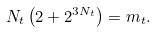Convert formula to latex. <formula><loc_0><loc_0><loc_500><loc_500>N _ { t } \left ( 2 + 2 ^ { 3 N _ { t } } \right ) = m _ { t } .</formula> 